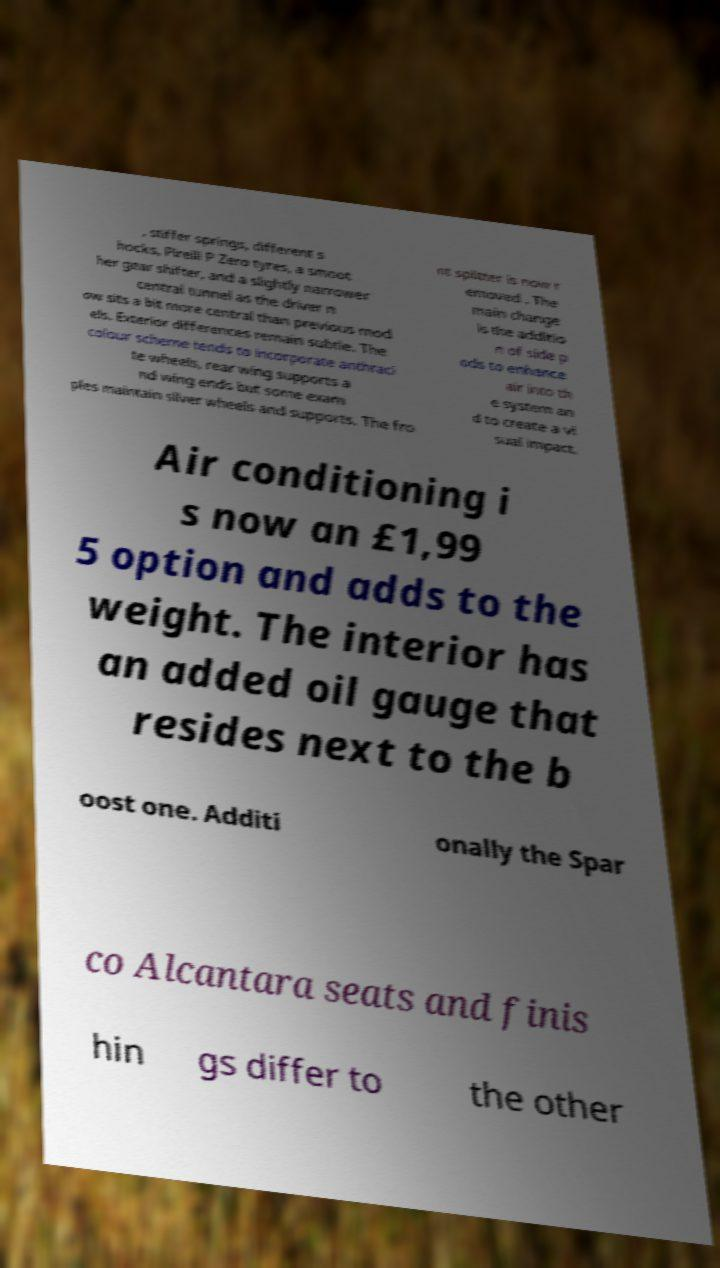Could you assist in decoding the text presented in this image and type it out clearly? , stiffer springs, different s hocks, Pirelli P Zero tyres, a smoot her gear shifter, and a slightly narrower central tunnel as the driver n ow sits a bit more central than previous mod els. Exterior differences remain subtle. The colour scheme tends to incorporate anthraci te wheels, rear wing supports a nd wing ends but some exam ples maintain silver wheels and supports. The fro nt splitter is now r emoved . The main change is the additio n of side p ods to enhance air into th e system an d to create a vi sual impact. Air conditioning i s now an £1,99 5 option and adds to the weight. The interior has an added oil gauge that resides next to the b oost one. Additi onally the Spar co Alcantara seats and finis hin gs differ to the other 